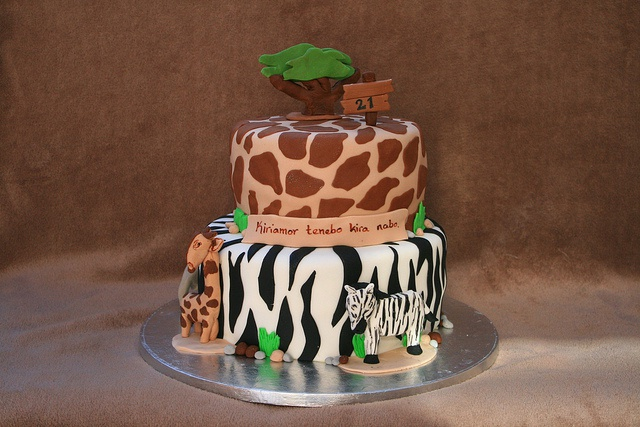Describe the objects in this image and their specific colors. I can see cake in black, maroon, lightgray, and tan tones and zebra in black, beige, tan, and darkgray tones in this image. 